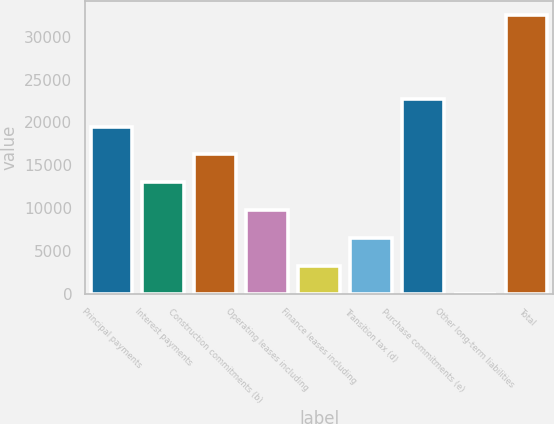<chart> <loc_0><loc_0><loc_500><loc_500><bar_chart><fcel>Principal payments<fcel>Interest payments<fcel>Construction commitments (b)<fcel>Operating leases including<fcel>Finance leases including<fcel>Transition tax (d)<fcel>Purchase commitments (e)<fcel>Other long-term liabilities<fcel>Total<nl><fcel>19503.8<fcel>13003.3<fcel>16253.6<fcel>9753.01<fcel>3252.45<fcel>6502.73<fcel>22754.1<fcel>2.17<fcel>32505<nl></chart> 